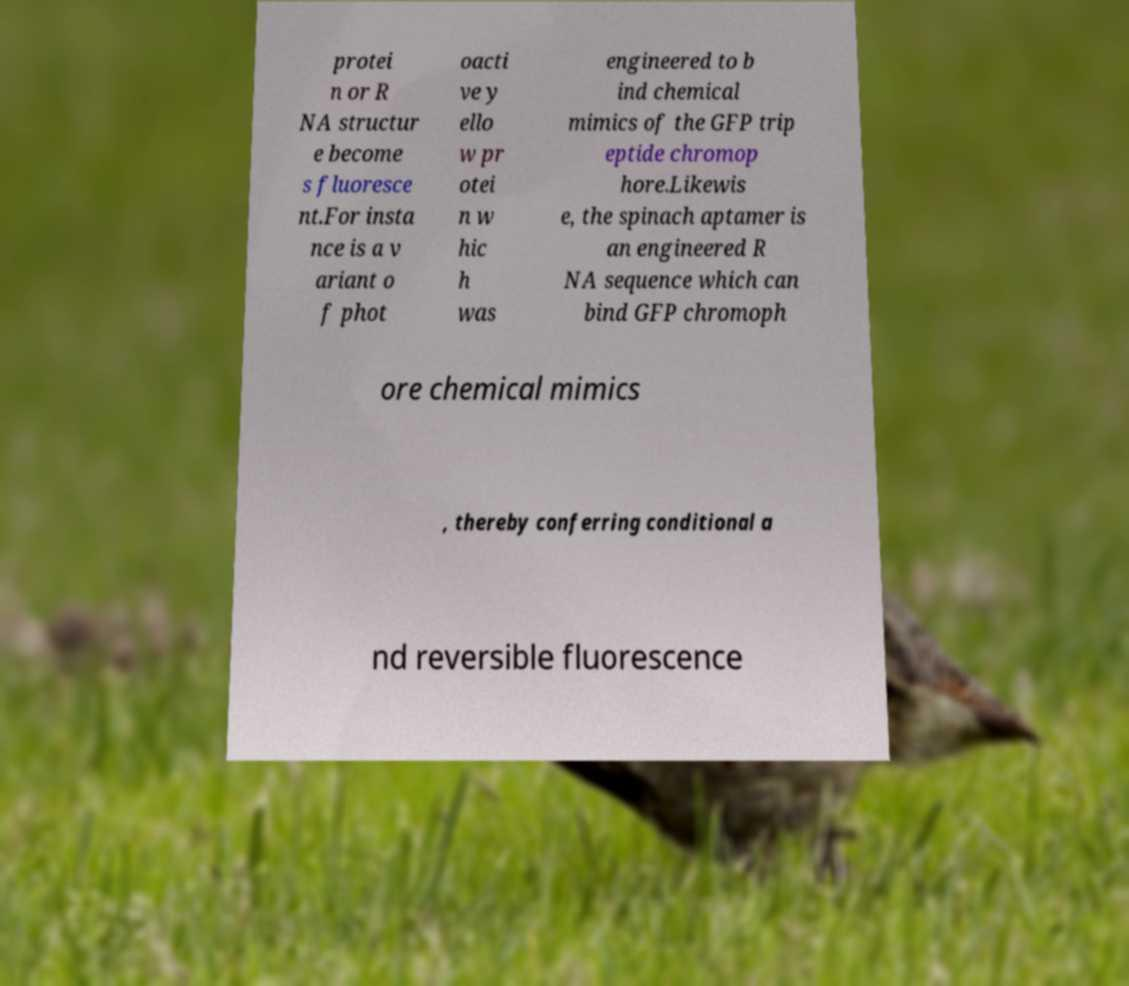Please identify and transcribe the text found in this image. protei n or R NA structur e become s fluoresce nt.For insta nce is a v ariant o f phot oacti ve y ello w pr otei n w hic h was engineered to b ind chemical mimics of the GFP trip eptide chromop hore.Likewis e, the spinach aptamer is an engineered R NA sequence which can bind GFP chromoph ore chemical mimics , thereby conferring conditional a nd reversible fluorescence 